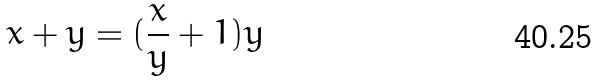Convert formula to latex. <formula><loc_0><loc_0><loc_500><loc_500>x + y = ( \frac { x } { y } + 1 ) y</formula> 